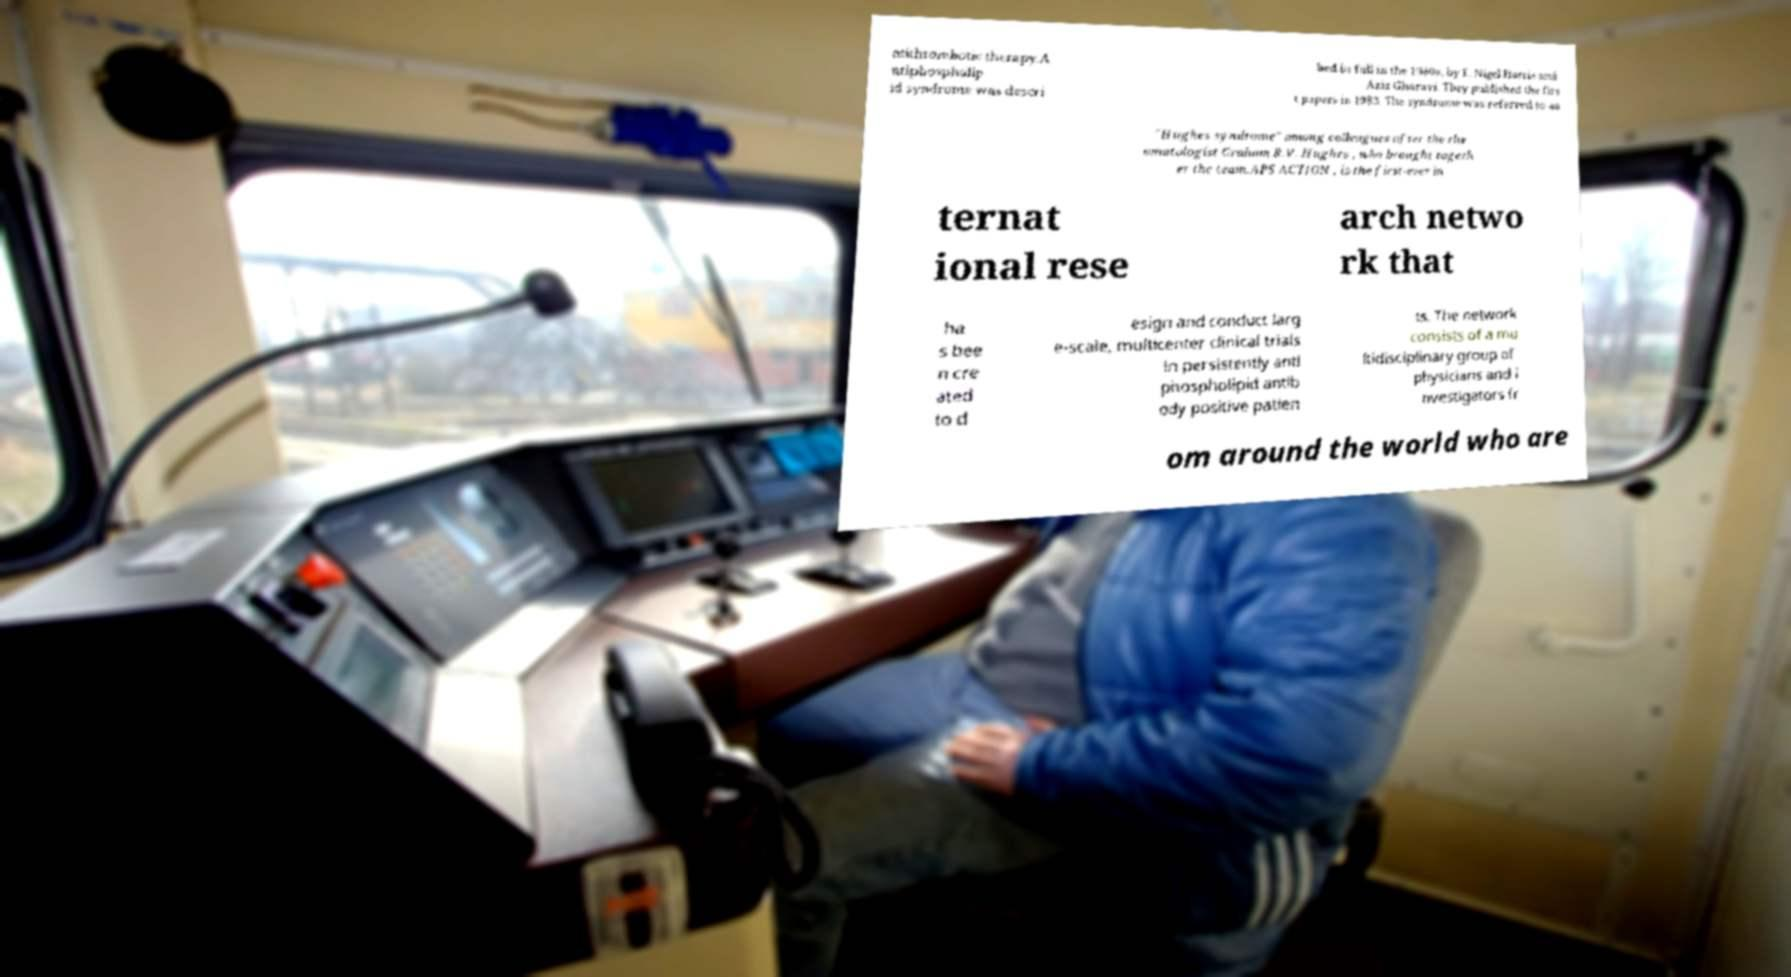Could you extract and type out the text from this image? ntithrombotic therapy.A ntiphospholip id syndrome was descri bed in full in the 1980s, by E. Nigel Harris and Aziz Gharavi. They published the firs t papers in 1983. The syndrome was referred to as "Hughes syndrome" among colleagues after the rhe umatologist Graham R.V. Hughes , who brought togeth er the team.APS ACTION , is the first-ever in ternat ional rese arch netwo rk that ha s bee n cre ated to d esign and conduct larg e-scale, multicenter clinical trials in persistently anti phospholipid antib ody positive patien ts. The network consists of a mu ltidisciplinary group of physicians and i nvestigators fr om around the world who are 